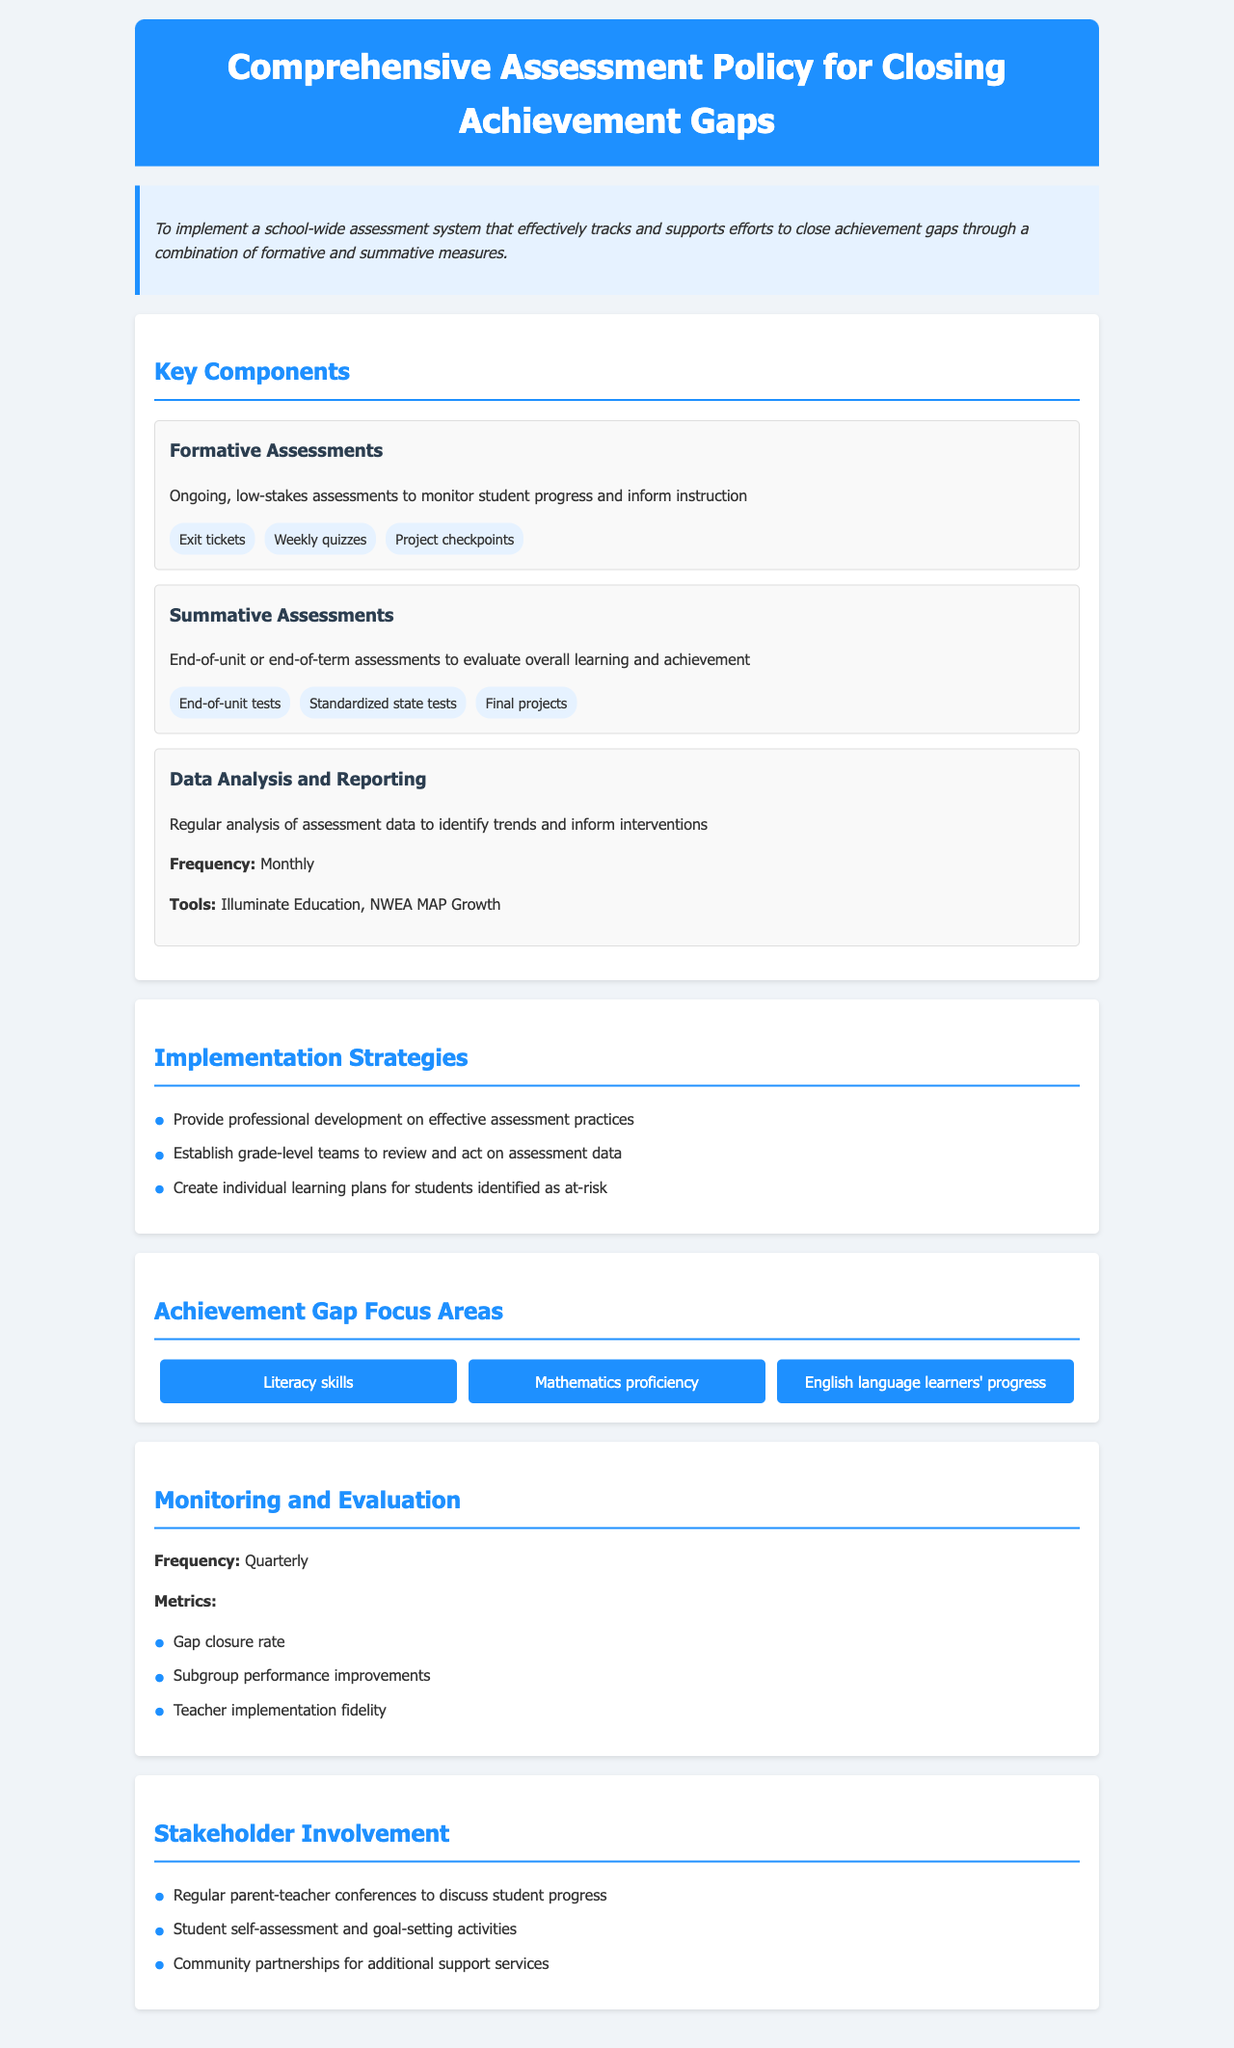What is the title of this policy document? The title is the main heading of the document which outlines its focus on assessment strategies in schools.
Answer: Comprehensive Assessment Policy for Closing Achievement Gaps What are formative assessments? Formative assessments are ongoing, low-stakes assessments designed to monitor student progress and inform instruction.
Answer: Ongoing, low-stakes assessments What is the frequency of data analysis and reporting? The frequency indicates how often data analysis and reporting will take place as specified in the document.
Answer: Monthly Name one tool mentioned for data analysis. The document specifies a few tools used for data analysis, so the answer includes one of those tools.
Answer: Illuminate Education How often will monitoring and evaluation occur? Monitoring and evaluation frequency helps determine how regularly progress will be assessed regarding achievement gaps.
Answer: Quarterly List one focus area for closing achievement gaps. The focus areas are specified sections within the document aimed at improving different student skills and progress.
Answer: Literacy skills What is one strategy for implementation mentioned? Implementation strategies provide methods to put the assessment policy into practice, and one of them will be referenced here.
Answer: Provide professional development What is one way to involve stakeholders? This question refers to strategies that include different community and student engagement practices mentioned in the policy.
Answer: Regular parent-teacher conferences 